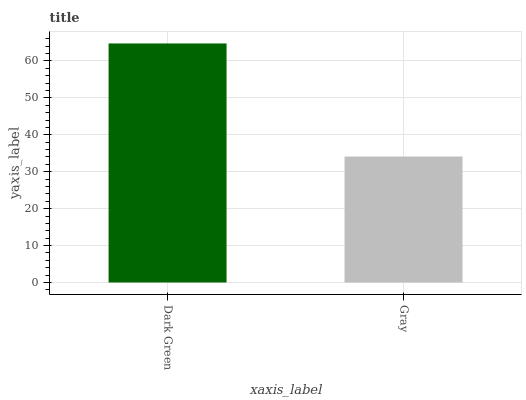Is Gray the minimum?
Answer yes or no. Yes. Is Dark Green the maximum?
Answer yes or no. Yes. Is Gray the maximum?
Answer yes or no. No. Is Dark Green greater than Gray?
Answer yes or no. Yes. Is Gray less than Dark Green?
Answer yes or no. Yes. Is Gray greater than Dark Green?
Answer yes or no. No. Is Dark Green less than Gray?
Answer yes or no. No. Is Dark Green the high median?
Answer yes or no. Yes. Is Gray the low median?
Answer yes or no. Yes. Is Gray the high median?
Answer yes or no. No. Is Dark Green the low median?
Answer yes or no. No. 